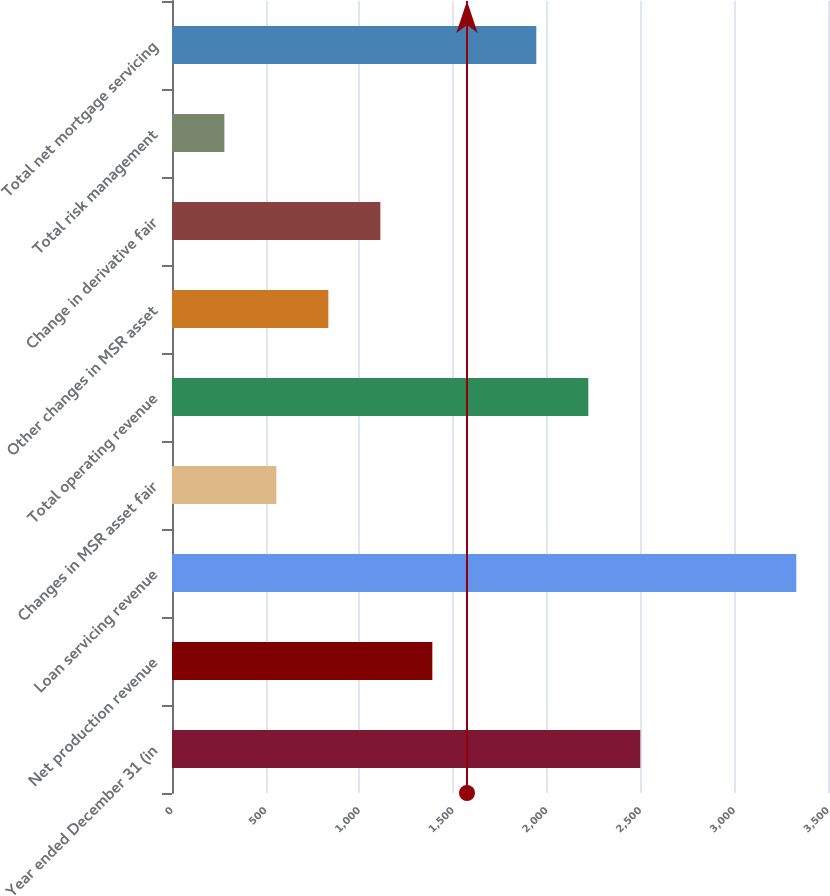<chart> <loc_0><loc_0><loc_500><loc_500><bar_chart><fcel>Year ended December 31 (in<fcel>Net production revenue<fcel>Loan servicing revenue<fcel>Changes in MSR asset fair<fcel>Total operating revenue<fcel>Other changes in MSR asset<fcel>Change in derivative fair<fcel>Total risk management<fcel>Total net mortgage servicing<nl><fcel>2498.6<fcel>1389<fcel>3330.8<fcel>556.8<fcel>2221.2<fcel>834.2<fcel>1111.6<fcel>279.4<fcel>1943.8<nl></chart> 